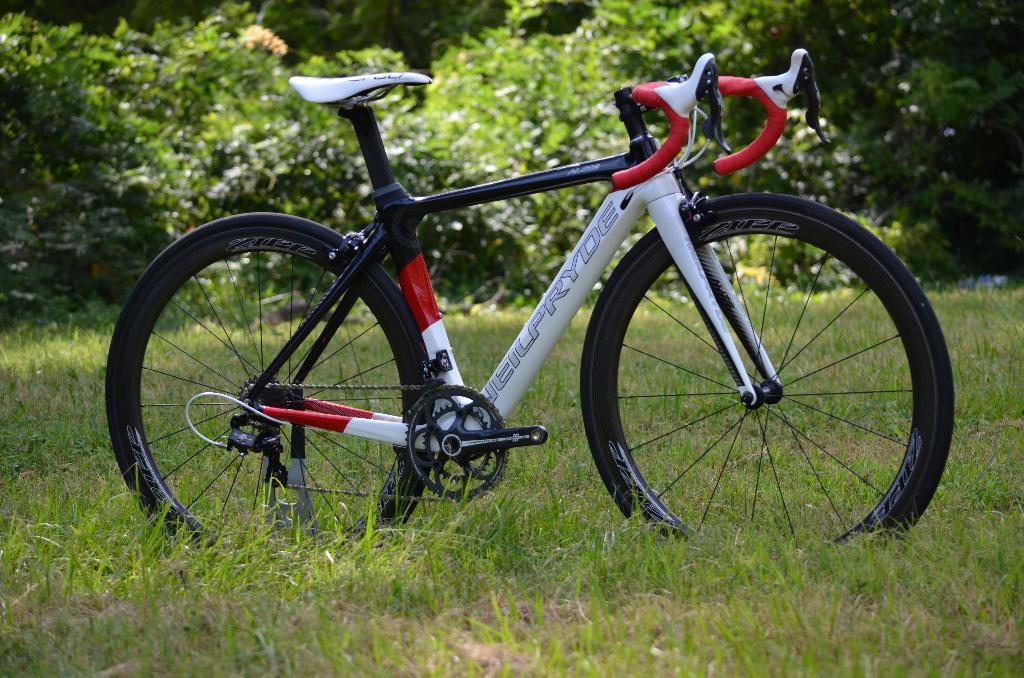What type of surface is visible in the image? There is a grass surface in the image. What is parked on the grass surface? A bicycle is parked on the grass surface. What can be seen behind the bicycle? There are plants visible behind the bicycle. Where is the grandfather sitting in the image? There is no grandfather present in the image. How many ducks are swimming in the pond in the image? There is no pond or ducks present in the image. 